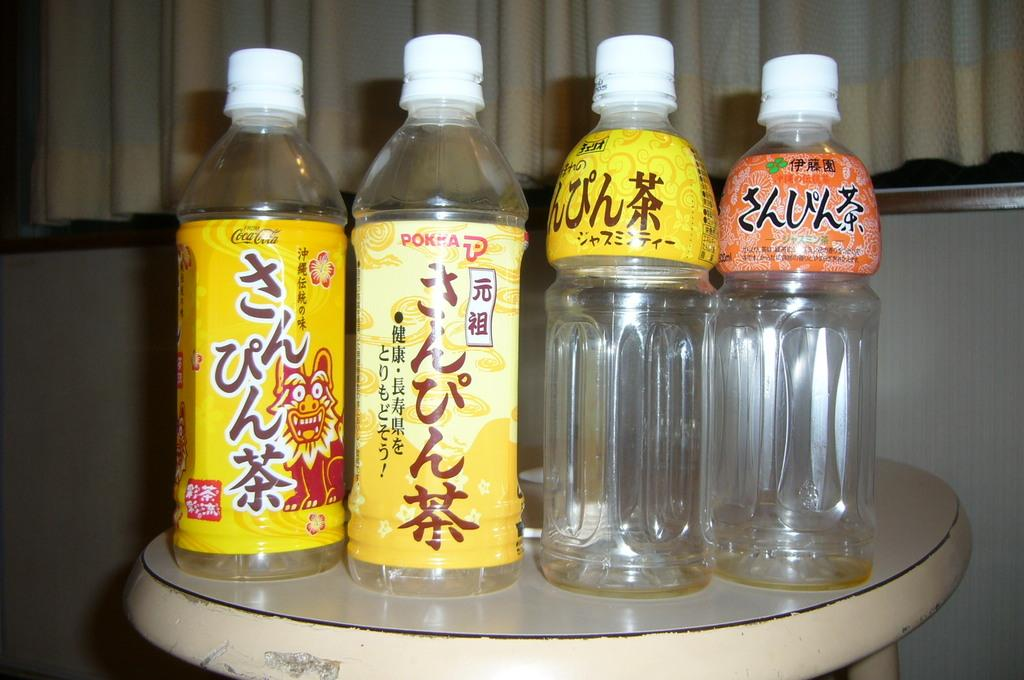<image>
Render a clear and concise summary of the photo. Four bottles are on a stool, and the one on the left is made by Coca-Cola. 